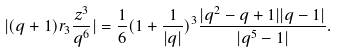Convert formula to latex. <formula><loc_0><loc_0><loc_500><loc_500>| ( q + 1 ) r _ { 3 } \frac { z ^ { 3 } } { q ^ { 6 } } | = \frac { 1 } { 6 } ( 1 + \frac { 1 } { | q | } ) ^ { 3 } \frac { | q ^ { 2 } - q + 1 | | q - 1 | } { | q ^ { 5 } - 1 | } .</formula> 